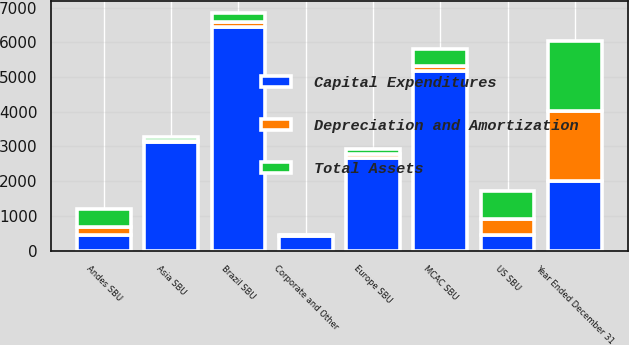<chart> <loc_0><loc_0><loc_500><loc_500><stacked_bar_chart><ecel><fcel>Year Ended December 31<fcel>US SBU<fcel>Andes SBU<fcel>Brazil SBU<fcel>MCAC SBU<fcel>Europe SBU<fcel>Asia SBU<fcel>Corporate and Other<nl><fcel>Capital Expenditures<fcel>2016<fcel>449.5<fcel>449.5<fcel>6448<fcel>5162<fcel>2664<fcel>3113<fcel>428<nl><fcel>Depreciation and Amortization<fcel>2016<fcel>471<fcel>218<fcel>145<fcel>165<fcel>116<fcel>33<fcel>12<nl><fcel>Total Assets<fcel>2016<fcel>809<fcel>538<fcel>264<fcel>480<fcel>143<fcel>136<fcel>18<nl></chart> 